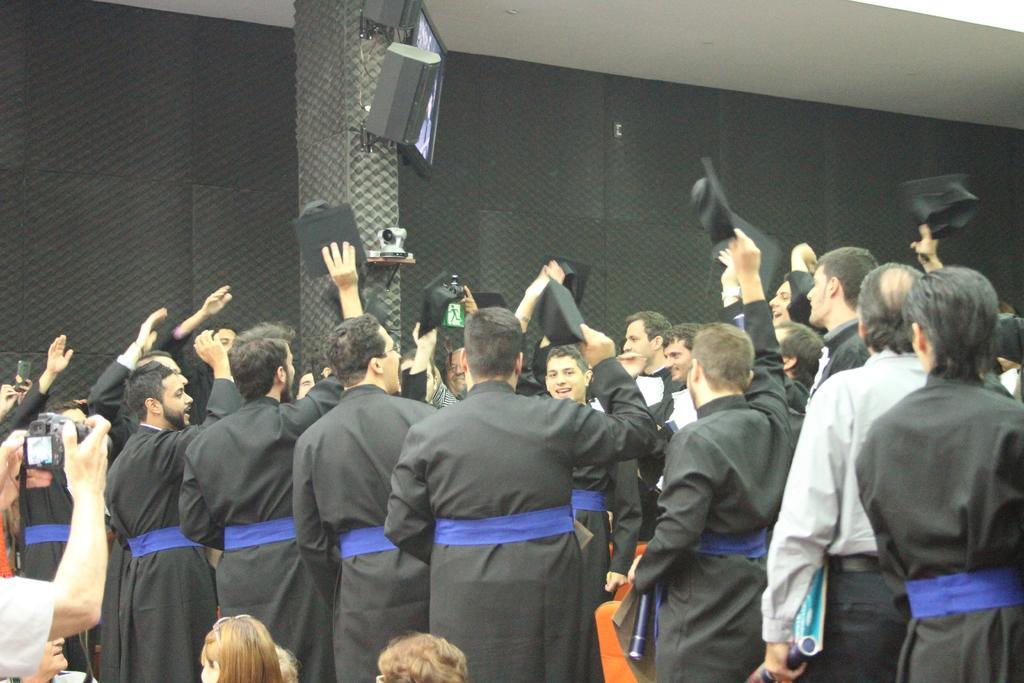Could you give a brief overview of what you see in this image? In this picture we can see a group of people, some people are holding hats, one person is holding a camera and in the background we can see a pillar, wall, camera, speakers, screen. 